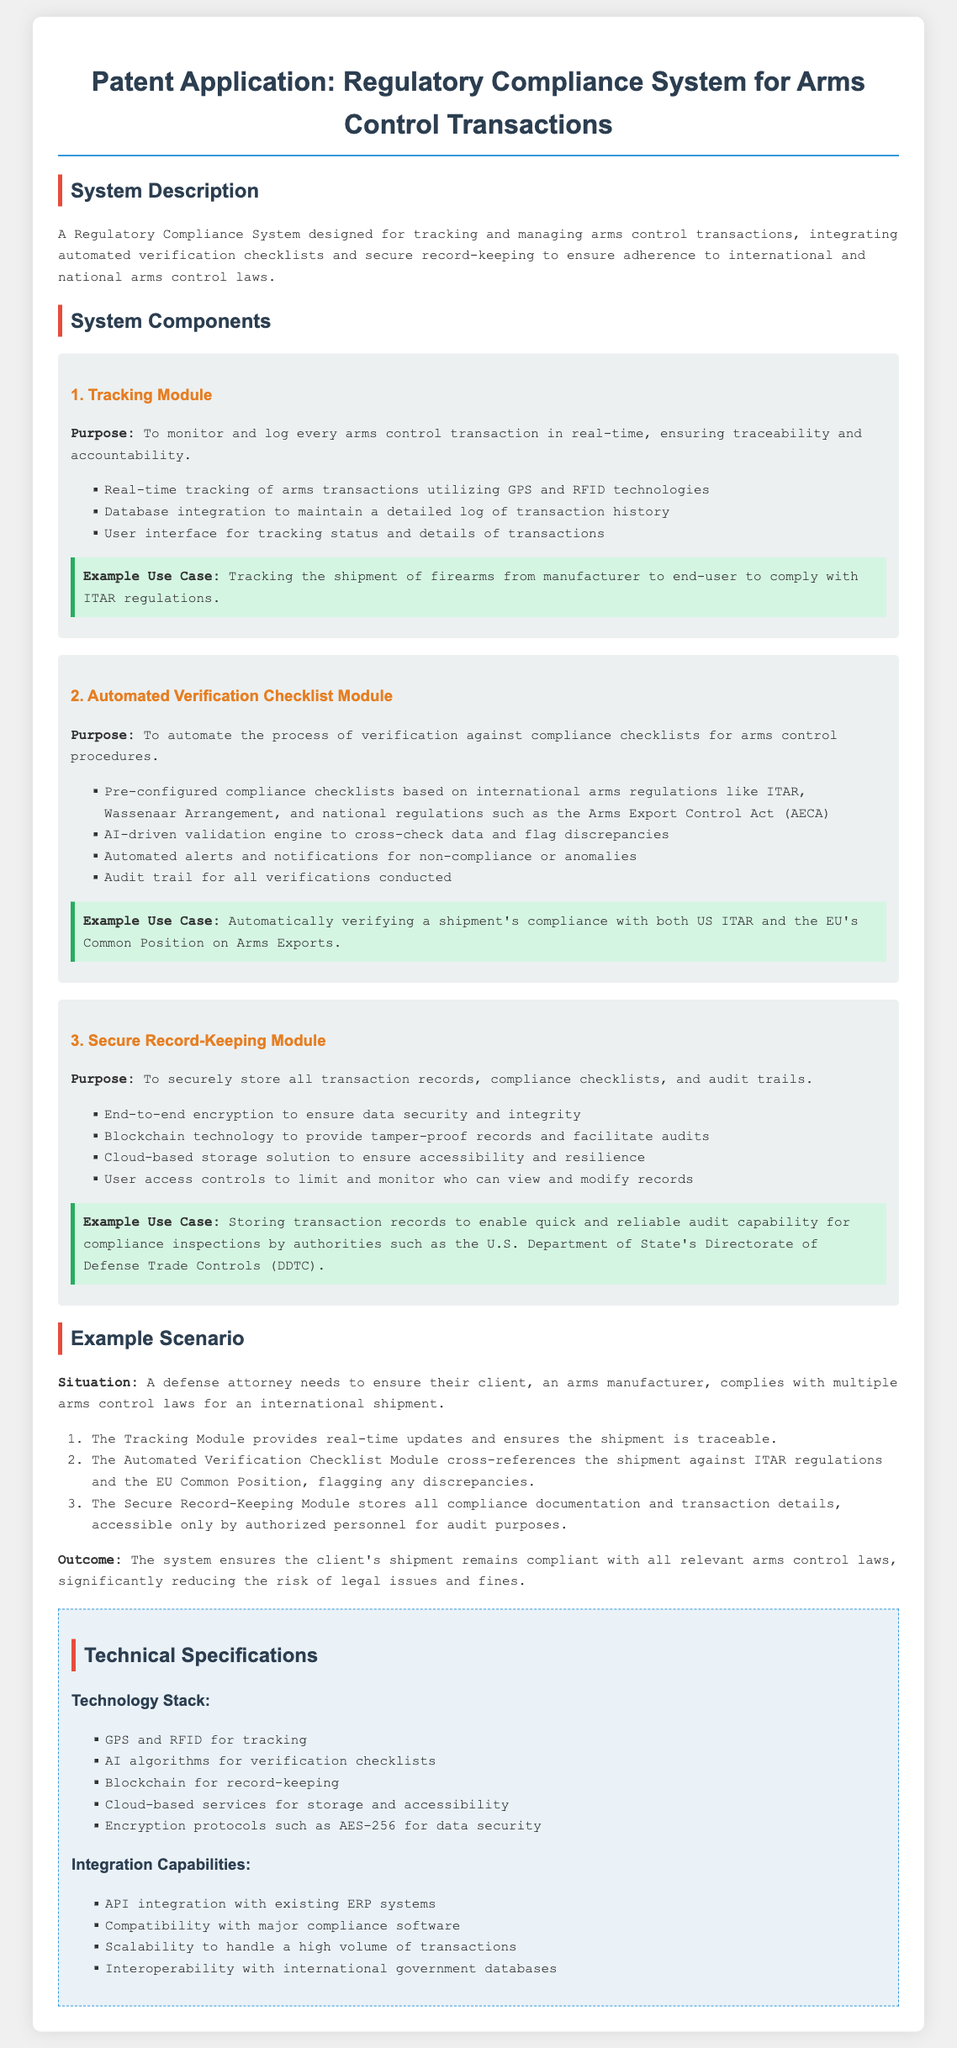What is the title of the patent application? The title is stated in the document header, indicating the subject of the application.
Answer: Regulatory Compliance System for Arms Control Transactions What technology is used for tracking arms transactions? The document specifies the technologies employed in the Tracking Module for monitoring purposes.
Answer: GPS and RFID Which regulatory acts are referenced in the Automated Verification Checklist Module? The document lists specific regulations that are used for automation in compliance verification.
Answer: ITAR, Wassenaar Arrangement, Arms Export Control Act What encryption protocol is mentioned for data security? The document describes the security measures to protect stored records and specifies the encryption protocol utilized.
Answer: AES-256 What is the purpose of the Secure Record-Keeping Module? The specific function of the Secure Record-Keeping Module is outlined in the document, explaining its role.
Answer: To securely store all transaction records, compliance checklists, and audit trails What is one example use case for the Tracking Module? The document provides a specific scenario to illustrate how the Tracking Module might be applied in practice.
Answer: Tracking the shipment of firearms from manufacturer to end-user In what scenario does the example scenario occur? The document outlines a situation to discuss how the system can be applied for a specific type of user.
Answer: When a defense attorney needs to ensure compliance What type of technology is used for record-keeping? The document clearly states the technology involved in maintaining secure transaction records.
Answer: Blockchain What does the system ensure regarding legal issues and fines? The document concludes with a statement about the system's impact on compliance-related risks.
Answer: Reducing the risk 